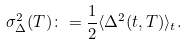<formula> <loc_0><loc_0><loc_500><loc_500>\sigma _ { \Delta } ^ { 2 } ( T ) \colon = \frac { 1 } { 2 } \langle \Delta ^ { 2 } ( t , T ) \rangle _ { t } .</formula> 